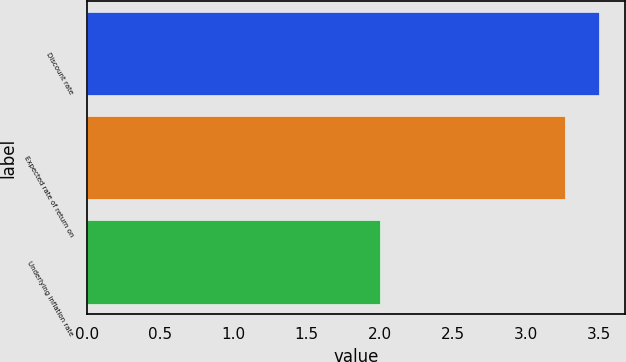<chart> <loc_0><loc_0><loc_500><loc_500><bar_chart><fcel>Discount rate<fcel>Expected rate of return on<fcel>Underlying inflation rate<nl><fcel>3.5<fcel>3.27<fcel>2<nl></chart> 